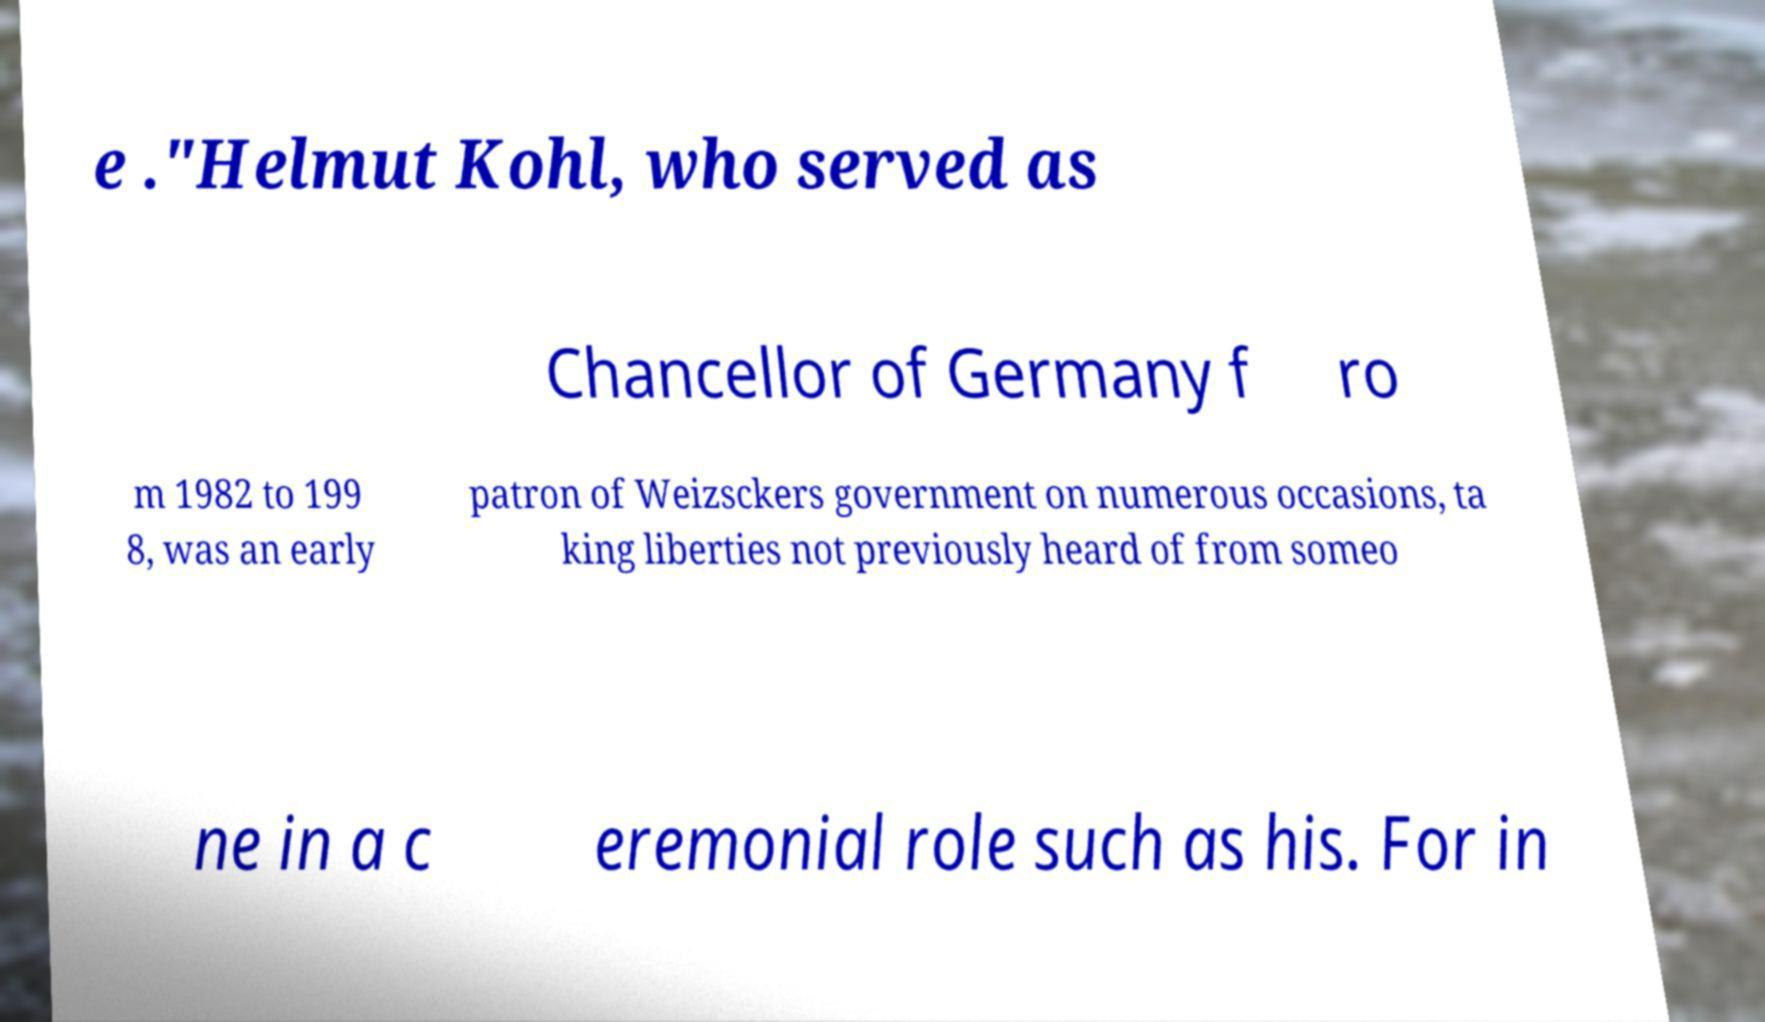Could you assist in decoding the text presented in this image and type it out clearly? e ."Helmut Kohl, who served as Chancellor of Germany f ro m 1982 to 199 8, was an early patron of Weizsckers government on numerous occasions, ta king liberties not previously heard of from someo ne in a c eremonial role such as his. For in 